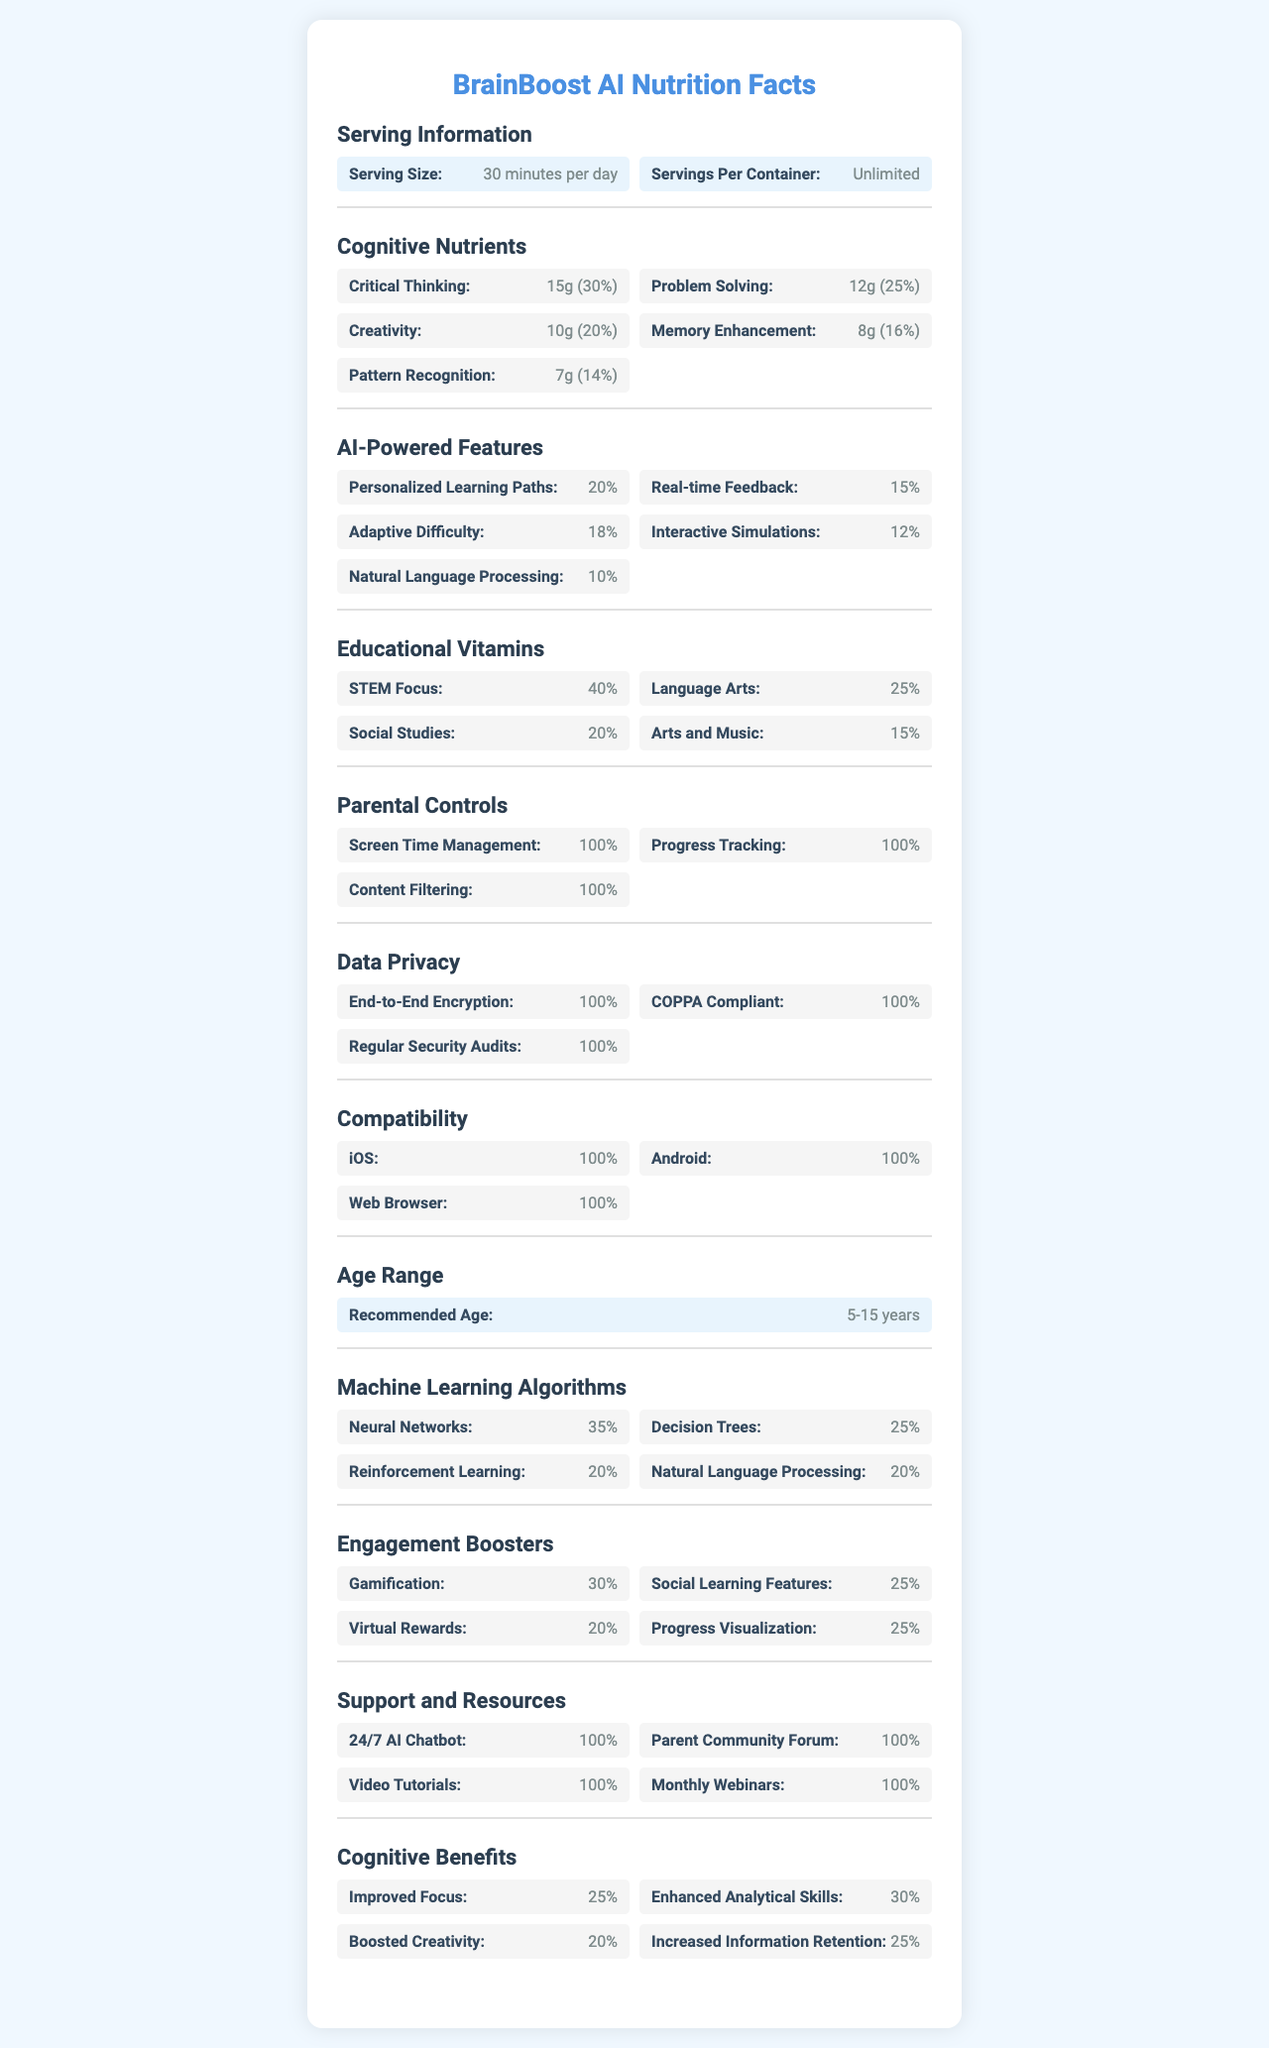What is the serving size for BrainBoost AI? The document states that the serving size is "30 minutes per day."
Answer: 30 minutes per day How much critical thinking is provided per serving of BrainBoost AI? In the Cognitive Nutrients section, it mentions that Critical Thinking is provided at 15g per serving.
Answer: 15g What percentage of the daily value for Memory Enhancement does BrainBoost AI provide? Under Cognitive Nutrients, Memory Enhancement has a daily value of 16%.
Answer: 16% How much Gamification is included in the Engagement Boosters? The Engagement Boosters section lists Gamification at 30%.
Answer: 30% What is the recommended age range for BrainBoost AI? The Age Range section mentions that the recommended age range is 5-15 years.
Answer: 5-15 years Which of the following AI-powered features has the highest percentage in BrainBoost AI? A. Personalized Learning Paths B. Real-time Feedback C. Adaptive Difficulty D. Interactive Simulations The AI-Powered Features section states that Personalized Learning Paths has a 20% share, which is the highest among the listed features.
Answer: A. Personalized Learning Paths How many platforms is BrainBoost AI compatible with? A. One B. Two C. Three D. Four The Compatibility section states that BrainBoost AI is compatible with iOS, Android, and Web Browser, totaling three platforms.
Answer: C. Three Is BrainBoost AI COPPA compliant? The Data Privacy section clearly states that BrainBoost AI is COPPA compliant.
Answer: Yes Summarize the main idea of the document. The document thoroughly details the features, benefits, and specifications of BrainBoost AI, emphasizing its role in cognitive development and its technical capabilities.
Answer: BrainBoost AI is an educational app designed to improve cognitive skills in children aged 5-15 through daily engagement of 30 minutes. It offers various cognitive nutrients like critical thinking and problem-solving while featuring AI-powered personalization, parental controls, and robust data privacy. Furthermore, the app is compatible with iOS, Android, and web browsers. What kind of data privacy features does BrainBoost AI offer? The Data Privacy section lists End-to-End Encryption, COPPA Compliance, and Regular Security Audits as key features.
Answer: End-to-End Encryption, COPPA Compliant, Regular Security Audits How much creative boost does BrainBoost AI provide per serving according to its daily value? The Cognitive Nutrients section lists Creativity at 20% of the daily value.
Answer: 20% Which type of machine learning algorithm has the highest percentage in BrainBoost AI? The Machine Learning Algorithms section indicates that Neural Networks have the highest percentage at 35%.
Answer: Neural Networks (35%) What is the amount of Social Learning Features included in the Engagement Boosters? The Engagement Boosters section specifies that Social Learning Features are included at 25%.
Answer: 25% Does BrainBoost AI offer content filtering as a parental control feature? The Parental Controls section mentions that Content Filtering is included as a feature.
Answer: Yes What are the specified educational vitamins focused on STEM subjects? Under Educational Vitamins, STEM Focus is listed at 40%.
Answer: 40% Does BrainBoost AI employ Support Vector Machines in its machine learning algorithms? The document does not mention Support Vector Machines in the Machine Learning Algorithms section or anywhere else.
Answer: Cannot be determined 